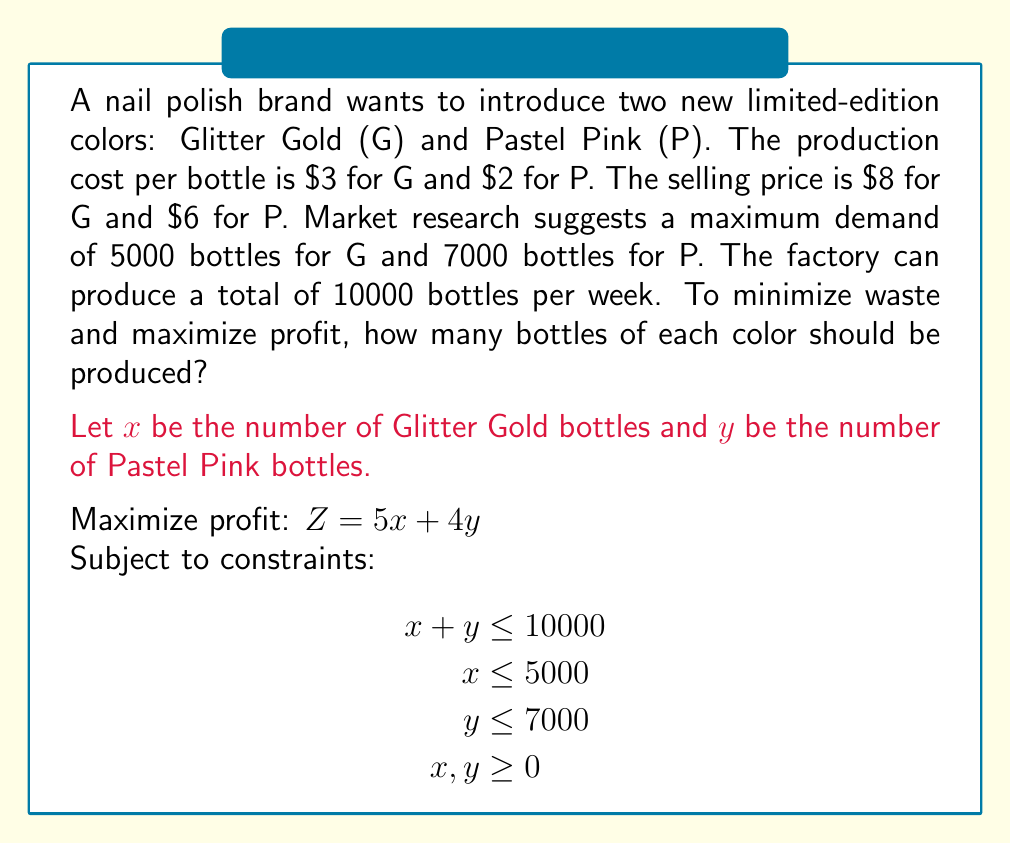Provide a solution to this math problem. To solve this linear programming problem, we'll use the graphical method:

1. Plot the constraints:
   - $x + y = 10000$ (production capacity)
   - $x = 5000$ (max demand for G)
   - $y = 7000$ (max demand for P)

2. Identify the feasible region (the area that satisfies all constraints).

3. Find the corner points of the feasible region:
   A (0, 7000)
   B (3000, 7000)
   C (5000, 5000)
   D (5000, 0)
   E (0, 0)

4. Evaluate the objective function $Z = 5x + 4y$ at each corner point:
   A: $Z = 5(0) + 4(7000) = 28000$
   B: $Z = 5(3000) + 4(7000) = 43000$
   C: $Z = 5(5000) + 4(5000) = 45000$
   D: $Z = 5(5000) + 4(0) = 25000$
   E: $Z = 5(0) + 4(0) = 0$

5. The maximum value of Z occurs at point C (5000, 5000).

Therefore, to maximize profit and minimize waste, the company should produce 5000 bottles of Glitter Gold and 5000 bottles of Pastel Pink.
Answer: 5000 bottles of Glitter Gold, 5000 bottles of Pastel Pink 